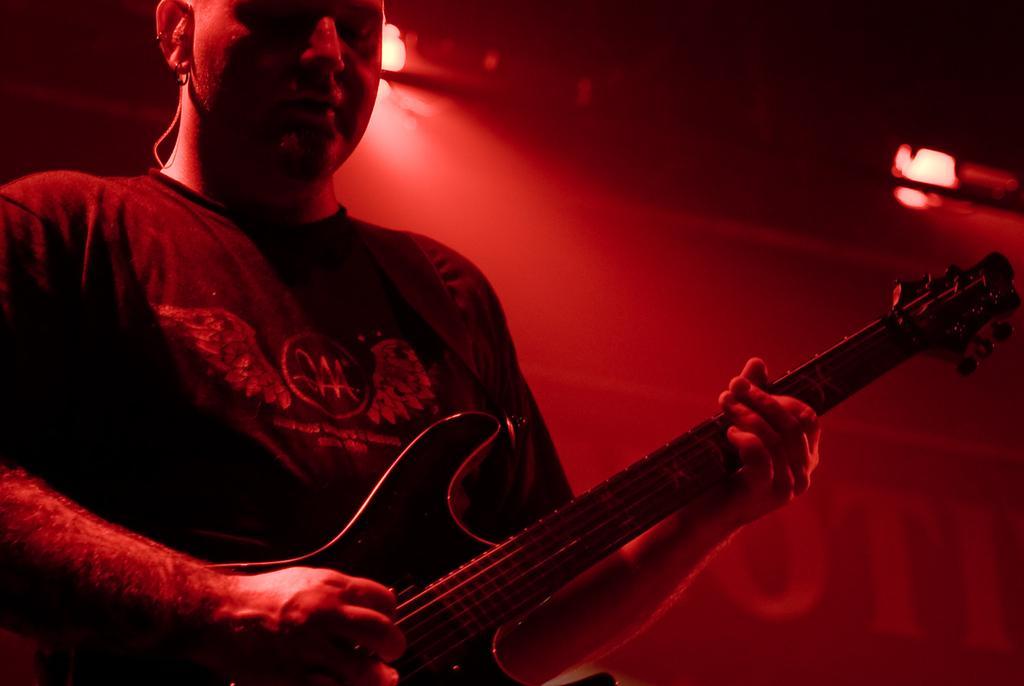Could you give a brief overview of what you see in this image? There is a man in this picture holding a guitar and playing it. In the background there is a red colored light. 